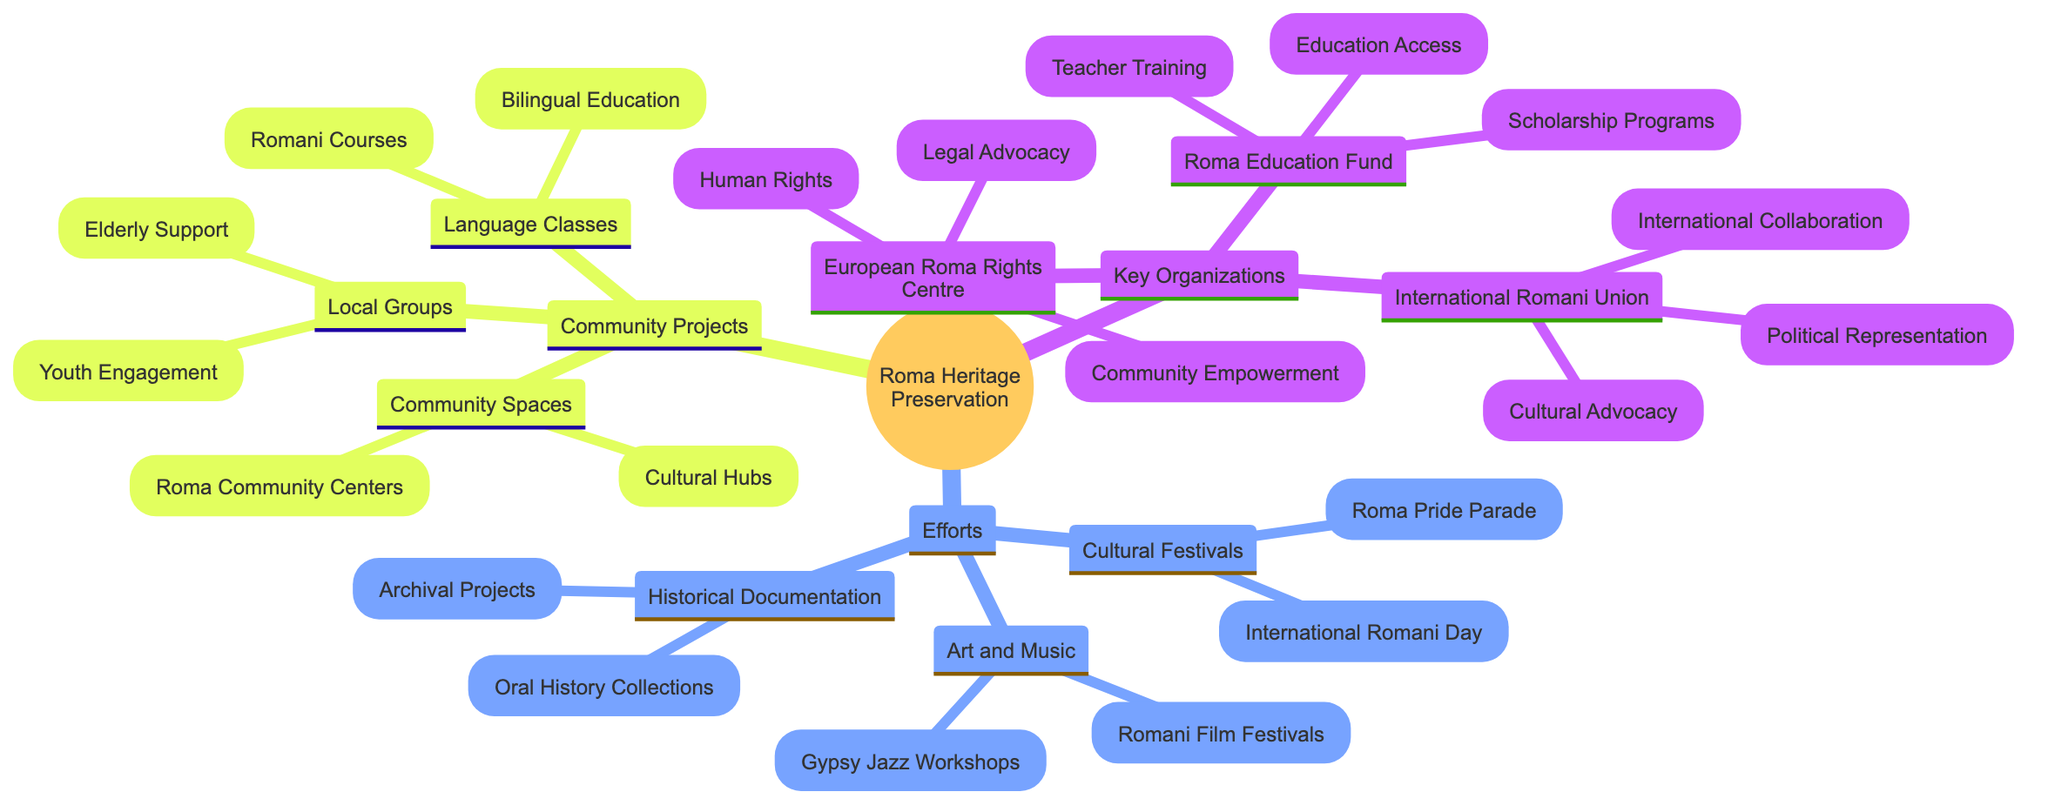What are the focus areas of the European Roma Rights Centre? The diagram directly lists the focus areas for the European Roma Rights Centre as "Human Rights," "Legal Advocacy," and "Community Empowerment."
Answer: Human Rights, Legal Advocacy, Community Empowerment How many key organizations are represented in the diagram? By counting each distinct node under the "Key Organizations" category, we find three organizations listed: "European Roma Rights Centre," "Roma Education Fund," and "International Romani Union."
Answer: 3 What types of events are organized under Cultural Festivals? The diagram specifies two events categorized under Cultural Festivals: "International Romani Day Celebrations" and "Roma Pride Parade."
Answer: International Romani Day Celebrations, Roma Pride Parade Which organization focuses on education access? The diagram indicates that the "Roma Education Fund" is focused on "Education Access," among other areas.
Answer: Roma Education Fund How many community spaces are mentioned? Under the "Community Spaces" category, the diagram indicates two examples: "Roma Community Centers" and "Cultural Hubs."
Answer: 2 What project is associated with the International Romani Union? The diagram includes "World Roma Congress" as one of the projects associated with the International Romani Union.
Answer: World Roma Congress Which efforts relate to art and music? The diagram lists two initiatives under the Art and Music efforts: "Romani Film Festivals" and "Gypsy Jazz Music Workshops."
Answer: Romani Film Festivals, Gypsy Jazz Music Workshops What types of initiatives are offered in Language Classes? Under the "Language Classes" segment, the diagram indicates two types of initiatives: "Romani Language Courses" and "Bilingual Education Programs."
Answer: Romani Language Courses, Bilingual Education Programs What is a focus area of the Roma Education Fund related to teacher development? The diagram shows "Teacher Training" as a focus area of the Roma Education Fund, which relates directly to teacher development.
Answer: Teacher Training 